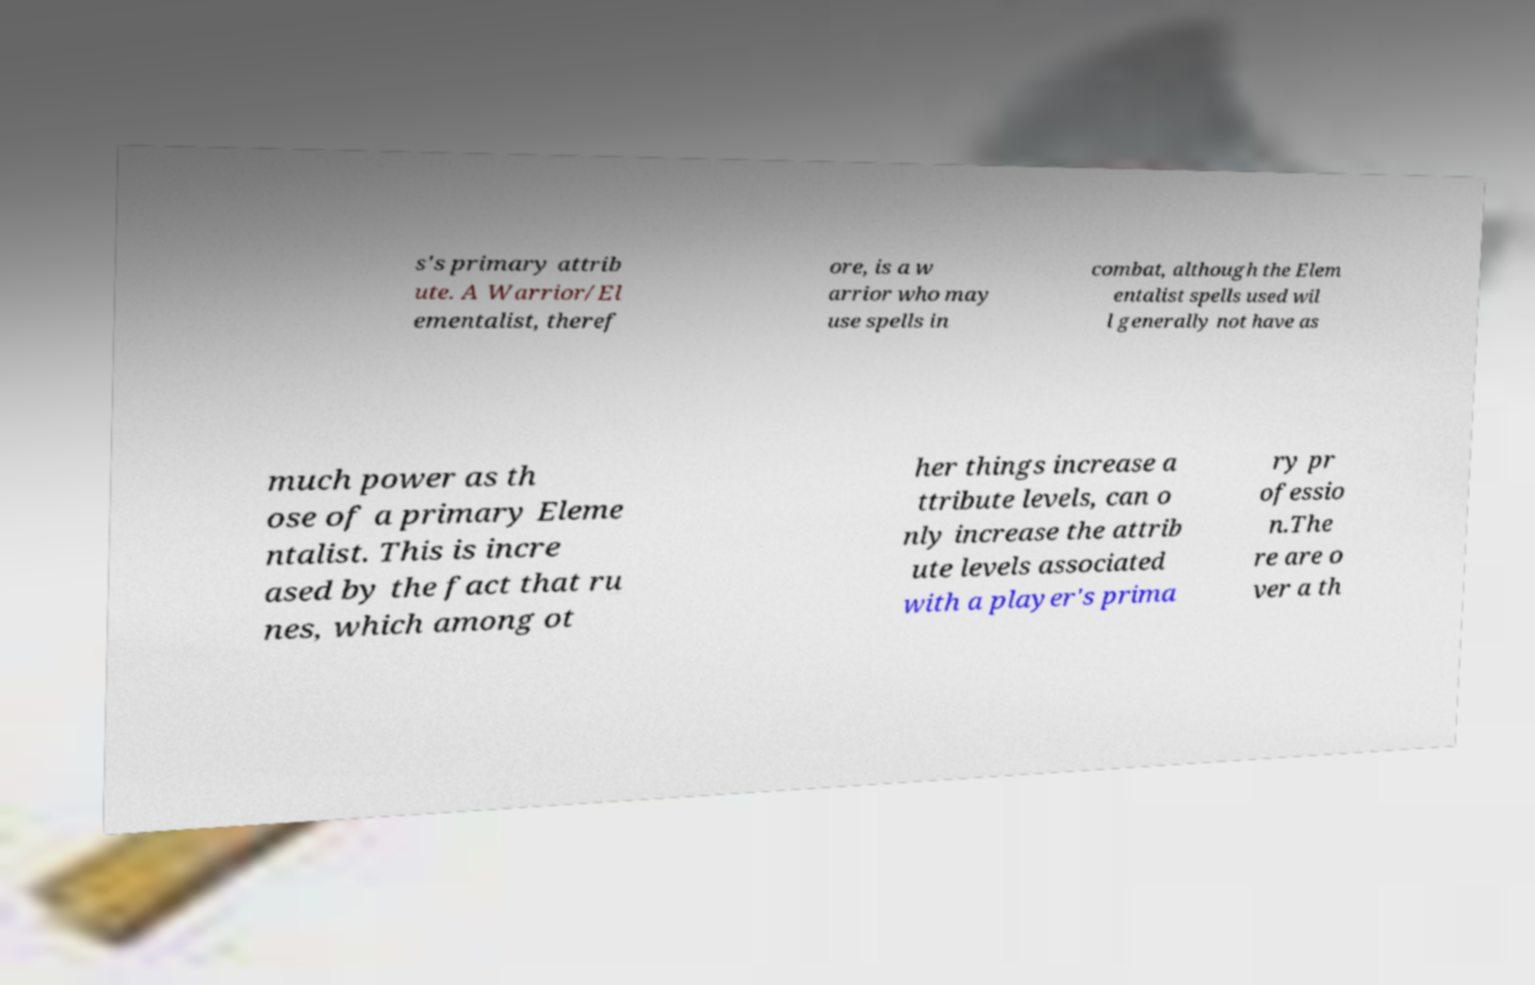What messages or text are displayed in this image? I need them in a readable, typed format. s's primary attrib ute. A Warrior/El ementalist, theref ore, is a w arrior who may use spells in combat, although the Elem entalist spells used wil l generally not have as much power as th ose of a primary Eleme ntalist. This is incre ased by the fact that ru nes, which among ot her things increase a ttribute levels, can o nly increase the attrib ute levels associated with a player's prima ry pr ofessio n.The re are o ver a th 